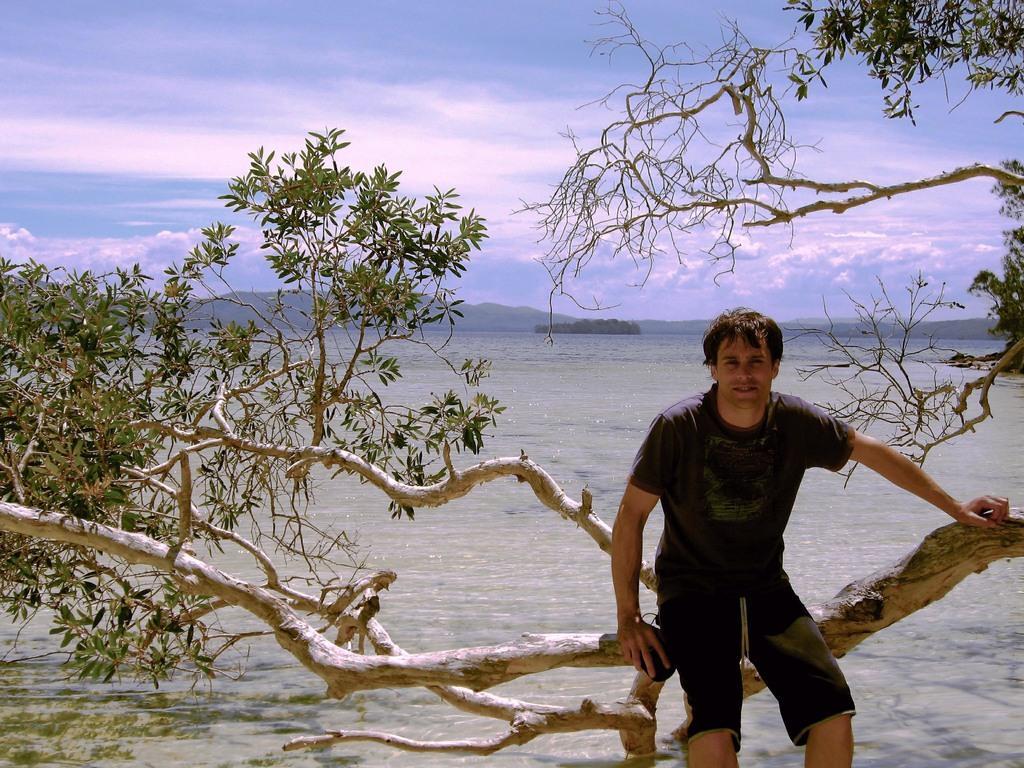Describe this image in one or two sentences. In this image I can see a person sitting on the tree and the tree is in green color. Background I can see water, mountains and the sky is in blue and white color. 